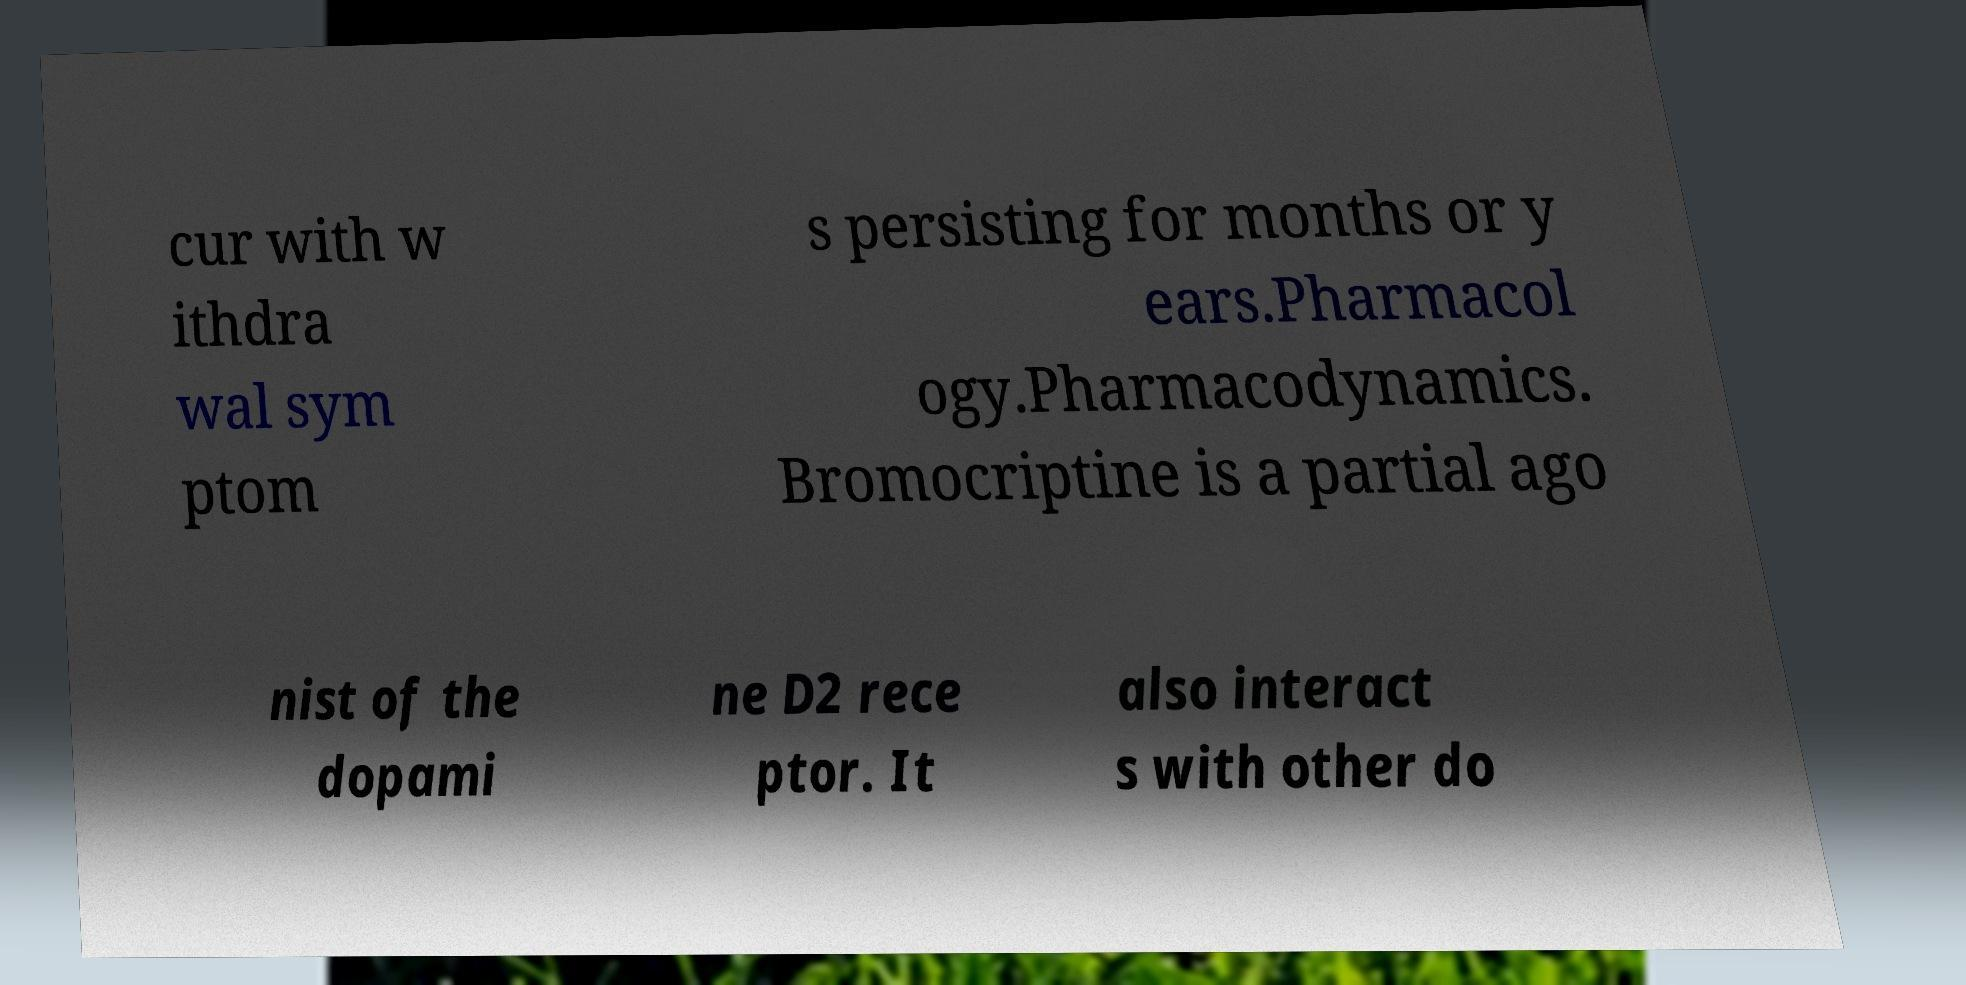What messages or text are displayed in this image? I need them in a readable, typed format. cur with w ithdra wal sym ptom s persisting for months or y ears.Pharmacol ogy.Pharmacodynamics. Bromocriptine is a partial ago nist of the dopami ne D2 rece ptor. It also interact s with other do 